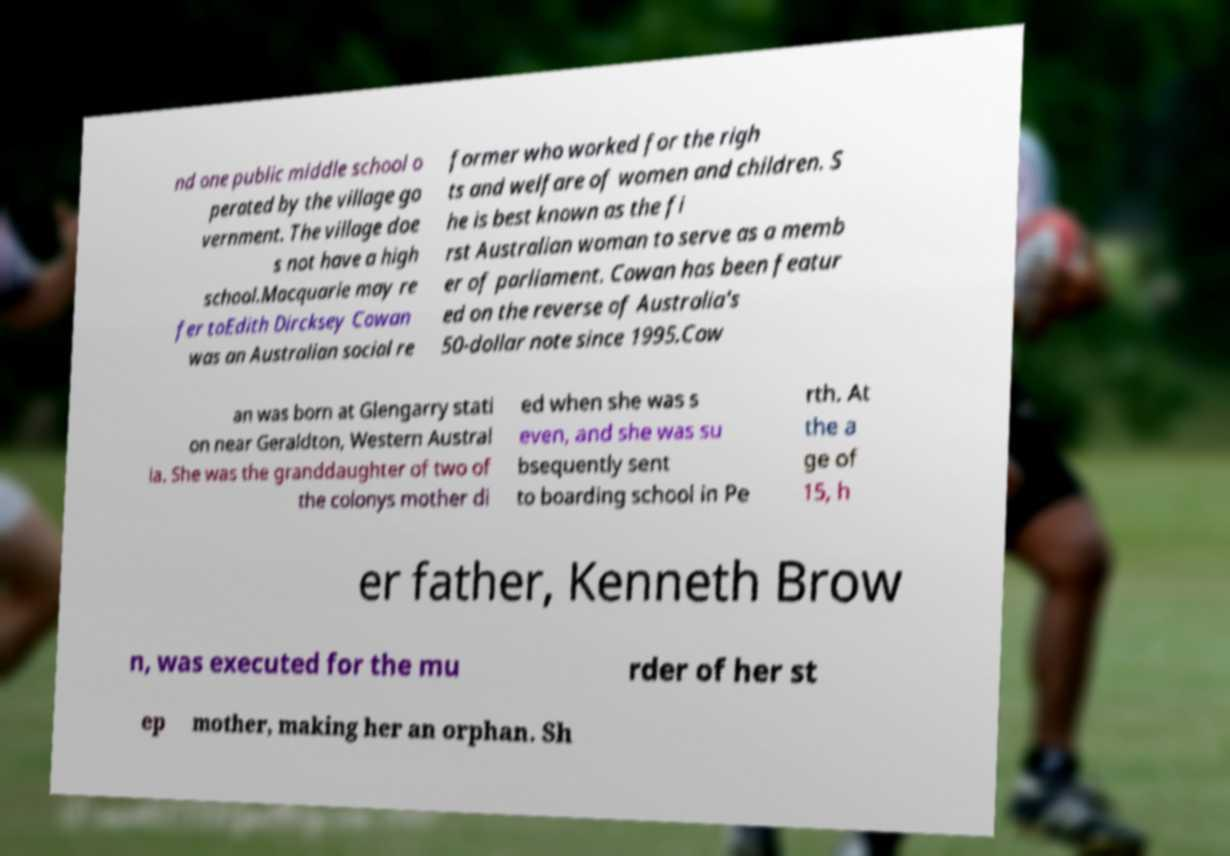Could you extract and type out the text from this image? nd one public middle school o perated by the village go vernment. The village doe s not have a high school.Macquarie may re fer toEdith Dircksey Cowan was an Australian social re former who worked for the righ ts and welfare of women and children. S he is best known as the fi rst Australian woman to serve as a memb er of parliament. Cowan has been featur ed on the reverse of Australia's 50-dollar note since 1995.Cow an was born at Glengarry stati on near Geraldton, Western Austral ia. She was the granddaughter of two of the colonys mother di ed when she was s even, and she was su bsequently sent to boarding school in Pe rth. At the a ge of 15, h er father, Kenneth Brow n, was executed for the mu rder of her st ep mother, making her an orphan. Sh 